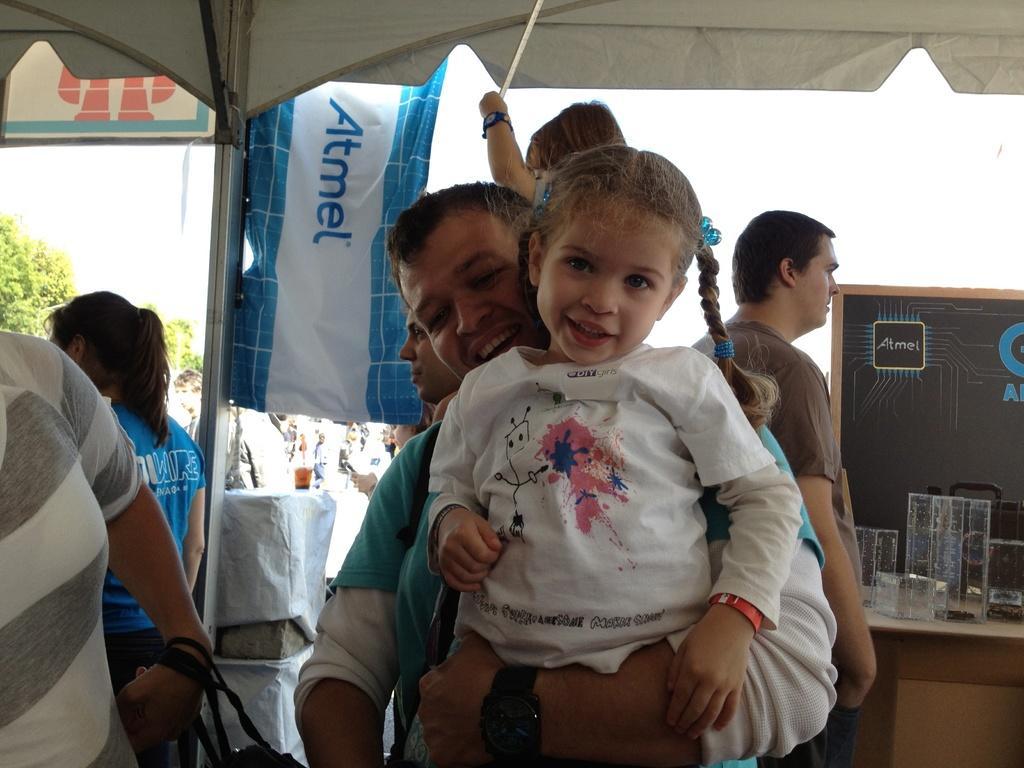How would you summarize this image in a sentence or two? In this image there are people. There is a table on the right side and there are glasses. There is a cloth at the top. There are trees. There is sky. 